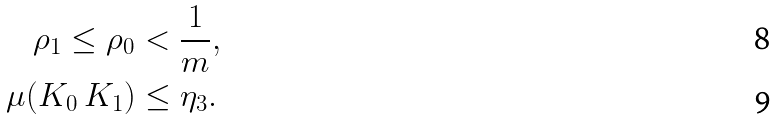<formula> <loc_0><loc_0><loc_500><loc_500>\rho _ { 1 } \leq \rho _ { 0 } & < \frac { 1 } { m } , \\ \mu ( K _ { 0 } \ K _ { 1 } ) & \leq \eta _ { 3 } .</formula> 